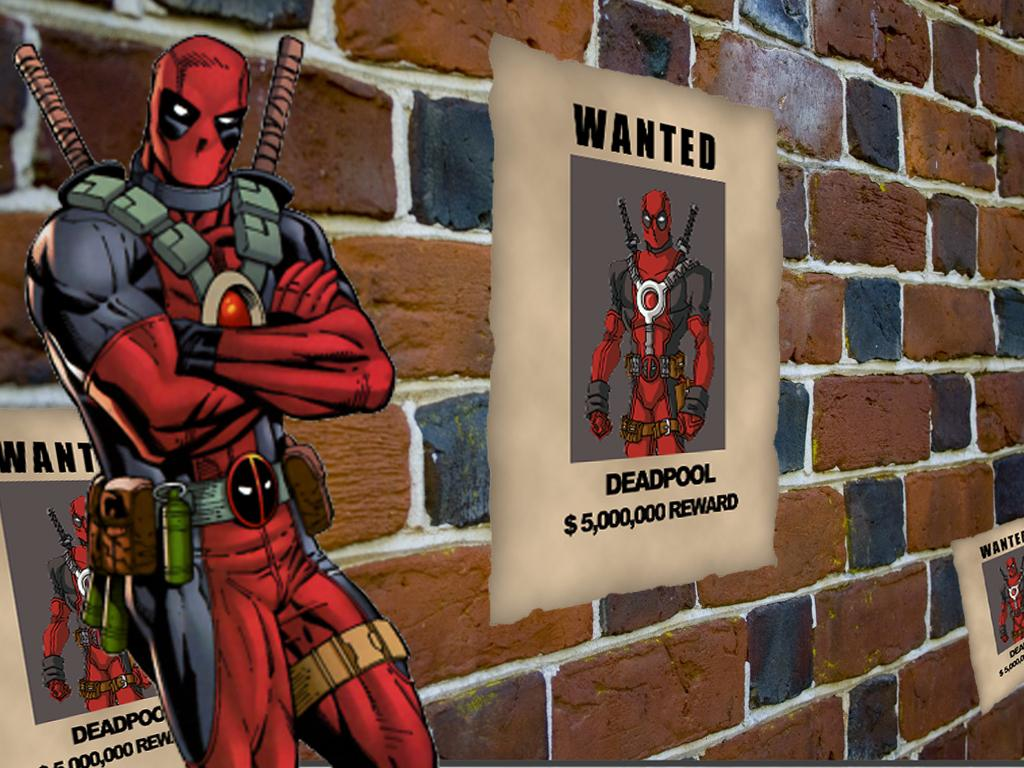<image>
Write a terse but informative summary of the picture. A wanted poster is on a brick wall that offers a $ 5,000,000 reward for Deadpool. 